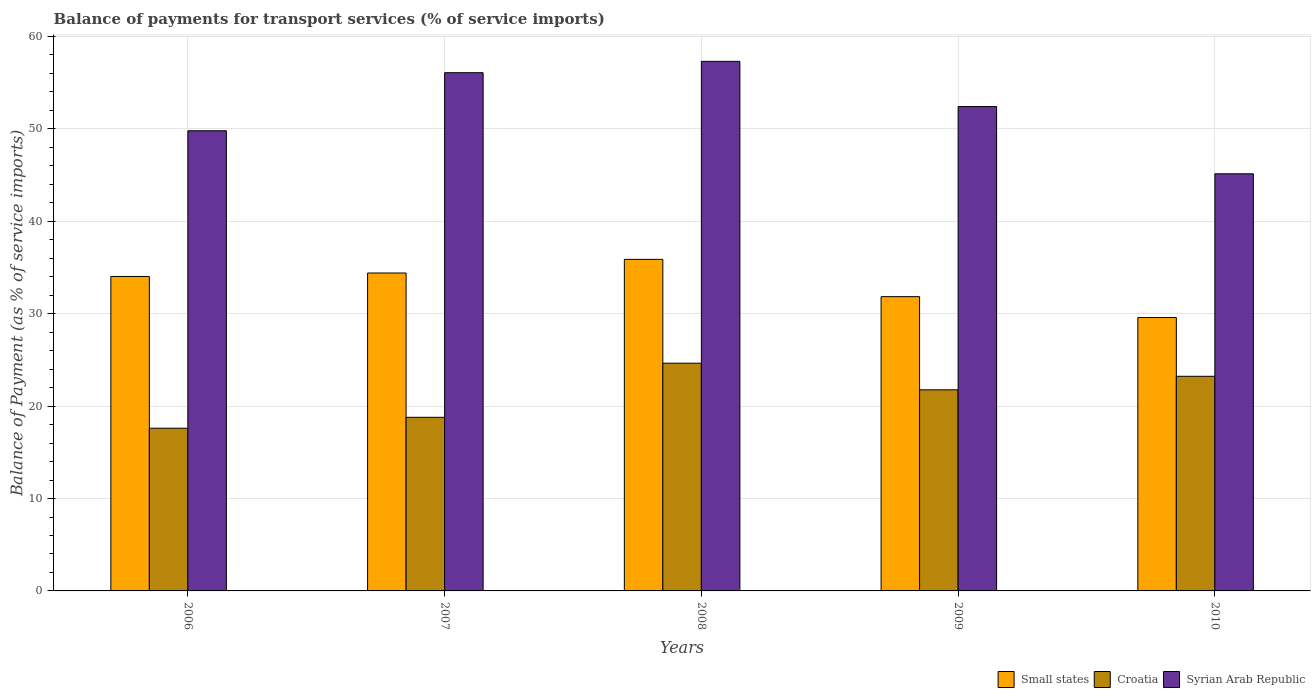Are the number of bars per tick equal to the number of legend labels?
Give a very brief answer. Yes. How many bars are there on the 2nd tick from the left?
Make the answer very short. 3. What is the label of the 4th group of bars from the left?
Your answer should be compact. 2009. What is the balance of payments for transport services in Small states in 2010?
Provide a short and direct response. 29.59. Across all years, what is the maximum balance of payments for transport services in Small states?
Make the answer very short. 35.88. Across all years, what is the minimum balance of payments for transport services in Syrian Arab Republic?
Give a very brief answer. 45.14. In which year was the balance of payments for transport services in Syrian Arab Republic maximum?
Ensure brevity in your answer.  2008. What is the total balance of payments for transport services in Small states in the graph?
Provide a short and direct response. 165.75. What is the difference between the balance of payments for transport services in Croatia in 2007 and that in 2010?
Provide a short and direct response. -4.44. What is the difference between the balance of payments for transport services in Small states in 2007 and the balance of payments for transport services in Syrian Arab Republic in 2010?
Your response must be concise. -10.74. What is the average balance of payments for transport services in Small states per year?
Make the answer very short. 33.15. In the year 2009, what is the difference between the balance of payments for transport services in Croatia and balance of payments for transport services in Small states?
Give a very brief answer. -10.08. In how many years, is the balance of payments for transport services in Syrian Arab Republic greater than 46 %?
Keep it short and to the point. 4. What is the ratio of the balance of payments for transport services in Syrian Arab Republic in 2008 to that in 2010?
Give a very brief answer. 1.27. What is the difference between the highest and the second highest balance of payments for transport services in Syrian Arab Republic?
Your answer should be very brief. 1.23. What is the difference between the highest and the lowest balance of payments for transport services in Syrian Arab Republic?
Offer a very short reply. 12.17. What does the 1st bar from the left in 2009 represents?
Give a very brief answer. Small states. What does the 3rd bar from the right in 2006 represents?
Provide a succinct answer. Small states. Is it the case that in every year, the sum of the balance of payments for transport services in Syrian Arab Republic and balance of payments for transport services in Small states is greater than the balance of payments for transport services in Croatia?
Provide a succinct answer. Yes. How many years are there in the graph?
Your answer should be compact. 5. What is the difference between two consecutive major ticks on the Y-axis?
Offer a terse response. 10. Does the graph contain grids?
Make the answer very short. Yes. Where does the legend appear in the graph?
Your answer should be very brief. Bottom right. What is the title of the graph?
Offer a terse response. Balance of payments for transport services (% of service imports). Does "Poland" appear as one of the legend labels in the graph?
Provide a succinct answer. No. What is the label or title of the Y-axis?
Offer a very short reply. Balance of Payment (as % of service imports). What is the Balance of Payment (as % of service imports) of Small states in 2006?
Give a very brief answer. 34.03. What is the Balance of Payment (as % of service imports) in Croatia in 2006?
Offer a terse response. 17.61. What is the Balance of Payment (as % of service imports) in Syrian Arab Republic in 2006?
Your answer should be very brief. 49.8. What is the Balance of Payment (as % of service imports) in Small states in 2007?
Give a very brief answer. 34.41. What is the Balance of Payment (as % of service imports) of Croatia in 2007?
Provide a short and direct response. 18.79. What is the Balance of Payment (as % of service imports) in Syrian Arab Republic in 2007?
Offer a terse response. 56.08. What is the Balance of Payment (as % of service imports) of Small states in 2008?
Your answer should be compact. 35.88. What is the Balance of Payment (as % of service imports) of Croatia in 2008?
Offer a very short reply. 24.65. What is the Balance of Payment (as % of service imports) of Syrian Arab Republic in 2008?
Your answer should be very brief. 57.31. What is the Balance of Payment (as % of service imports) in Small states in 2009?
Keep it short and to the point. 31.85. What is the Balance of Payment (as % of service imports) of Croatia in 2009?
Your response must be concise. 21.76. What is the Balance of Payment (as % of service imports) in Syrian Arab Republic in 2009?
Offer a very short reply. 52.42. What is the Balance of Payment (as % of service imports) of Small states in 2010?
Your answer should be compact. 29.59. What is the Balance of Payment (as % of service imports) in Croatia in 2010?
Keep it short and to the point. 23.23. What is the Balance of Payment (as % of service imports) in Syrian Arab Republic in 2010?
Give a very brief answer. 45.14. Across all years, what is the maximum Balance of Payment (as % of service imports) of Small states?
Your response must be concise. 35.88. Across all years, what is the maximum Balance of Payment (as % of service imports) in Croatia?
Make the answer very short. 24.65. Across all years, what is the maximum Balance of Payment (as % of service imports) in Syrian Arab Republic?
Your response must be concise. 57.31. Across all years, what is the minimum Balance of Payment (as % of service imports) in Small states?
Your response must be concise. 29.59. Across all years, what is the minimum Balance of Payment (as % of service imports) in Croatia?
Ensure brevity in your answer.  17.61. Across all years, what is the minimum Balance of Payment (as % of service imports) of Syrian Arab Republic?
Offer a terse response. 45.14. What is the total Balance of Payment (as % of service imports) of Small states in the graph?
Provide a short and direct response. 165.75. What is the total Balance of Payment (as % of service imports) of Croatia in the graph?
Your answer should be very brief. 106.04. What is the total Balance of Payment (as % of service imports) in Syrian Arab Republic in the graph?
Your answer should be compact. 260.76. What is the difference between the Balance of Payment (as % of service imports) in Small states in 2006 and that in 2007?
Offer a very short reply. -0.38. What is the difference between the Balance of Payment (as % of service imports) in Croatia in 2006 and that in 2007?
Make the answer very short. -1.18. What is the difference between the Balance of Payment (as % of service imports) of Syrian Arab Republic in 2006 and that in 2007?
Make the answer very short. -6.28. What is the difference between the Balance of Payment (as % of service imports) of Small states in 2006 and that in 2008?
Ensure brevity in your answer.  -1.85. What is the difference between the Balance of Payment (as % of service imports) of Croatia in 2006 and that in 2008?
Your answer should be very brief. -7.04. What is the difference between the Balance of Payment (as % of service imports) of Syrian Arab Republic in 2006 and that in 2008?
Keep it short and to the point. -7.51. What is the difference between the Balance of Payment (as % of service imports) in Small states in 2006 and that in 2009?
Your answer should be very brief. 2.18. What is the difference between the Balance of Payment (as % of service imports) of Croatia in 2006 and that in 2009?
Offer a very short reply. -4.15. What is the difference between the Balance of Payment (as % of service imports) in Syrian Arab Republic in 2006 and that in 2009?
Your answer should be very brief. -2.62. What is the difference between the Balance of Payment (as % of service imports) of Small states in 2006 and that in 2010?
Your answer should be very brief. 4.44. What is the difference between the Balance of Payment (as % of service imports) in Croatia in 2006 and that in 2010?
Make the answer very short. -5.62. What is the difference between the Balance of Payment (as % of service imports) of Syrian Arab Republic in 2006 and that in 2010?
Ensure brevity in your answer.  4.66. What is the difference between the Balance of Payment (as % of service imports) of Small states in 2007 and that in 2008?
Offer a very short reply. -1.48. What is the difference between the Balance of Payment (as % of service imports) in Croatia in 2007 and that in 2008?
Your answer should be compact. -5.86. What is the difference between the Balance of Payment (as % of service imports) in Syrian Arab Republic in 2007 and that in 2008?
Your response must be concise. -1.23. What is the difference between the Balance of Payment (as % of service imports) of Small states in 2007 and that in 2009?
Offer a terse response. 2.56. What is the difference between the Balance of Payment (as % of service imports) of Croatia in 2007 and that in 2009?
Provide a succinct answer. -2.97. What is the difference between the Balance of Payment (as % of service imports) of Syrian Arab Republic in 2007 and that in 2009?
Your answer should be compact. 3.66. What is the difference between the Balance of Payment (as % of service imports) in Small states in 2007 and that in 2010?
Offer a very short reply. 4.82. What is the difference between the Balance of Payment (as % of service imports) of Croatia in 2007 and that in 2010?
Provide a short and direct response. -4.44. What is the difference between the Balance of Payment (as % of service imports) of Syrian Arab Republic in 2007 and that in 2010?
Give a very brief answer. 10.94. What is the difference between the Balance of Payment (as % of service imports) of Small states in 2008 and that in 2009?
Your response must be concise. 4.03. What is the difference between the Balance of Payment (as % of service imports) in Croatia in 2008 and that in 2009?
Provide a short and direct response. 2.88. What is the difference between the Balance of Payment (as % of service imports) of Syrian Arab Republic in 2008 and that in 2009?
Your answer should be compact. 4.89. What is the difference between the Balance of Payment (as % of service imports) in Small states in 2008 and that in 2010?
Your answer should be compact. 6.3. What is the difference between the Balance of Payment (as % of service imports) of Croatia in 2008 and that in 2010?
Provide a succinct answer. 1.42. What is the difference between the Balance of Payment (as % of service imports) of Syrian Arab Republic in 2008 and that in 2010?
Make the answer very short. 12.17. What is the difference between the Balance of Payment (as % of service imports) of Small states in 2009 and that in 2010?
Your answer should be compact. 2.26. What is the difference between the Balance of Payment (as % of service imports) in Croatia in 2009 and that in 2010?
Your response must be concise. -1.46. What is the difference between the Balance of Payment (as % of service imports) of Syrian Arab Republic in 2009 and that in 2010?
Your response must be concise. 7.28. What is the difference between the Balance of Payment (as % of service imports) of Small states in 2006 and the Balance of Payment (as % of service imports) of Croatia in 2007?
Offer a terse response. 15.24. What is the difference between the Balance of Payment (as % of service imports) of Small states in 2006 and the Balance of Payment (as % of service imports) of Syrian Arab Republic in 2007?
Provide a succinct answer. -22.05. What is the difference between the Balance of Payment (as % of service imports) in Croatia in 2006 and the Balance of Payment (as % of service imports) in Syrian Arab Republic in 2007?
Your response must be concise. -38.47. What is the difference between the Balance of Payment (as % of service imports) in Small states in 2006 and the Balance of Payment (as % of service imports) in Croatia in 2008?
Keep it short and to the point. 9.38. What is the difference between the Balance of Payment (as % of service imports) in Small states in 2006 and the Balance of Payment (as % of service imports) in Syrian Arab Republic in 2008?
Keep it short and to the point. -23.28. What is the difference between the Balance of Payment (as % of service imports) in Croatia in 2006 and the Balance of Payment (as % of service imports) in Syrian Arab Republic in 2008?
Ensure brevity in your answer.  -39.7. What is the difference between the Balance of Payment (as % of service imports) of Small states in 2006 and the Balance of Payment (as % of service imports) of Croatia in 2009?
Your response must be concise. 12.27. What is the difference between the Balance of Payment (as % of service imports) of Small states in 2006 and the Balance of Payment (as % of service imports) of Syrian Arab Republic in 2009?
Your answer should be compact. -18.39. What is the difference between the Balance of Payment (as % of service imports) in Croatia in 2006 and the Balance of Payment (as % of service imports) in Syrian Arab Republic in 2009?
Provide a short and direct response. -34.81. What is the difference between the Balance of Payment (as % of service imports) of Small states in 2006 and the Balance of Payment (as % of service imports) of Croatia in 2010?
Your answer should be compact. 10.8. What is the difference between the Balance of Payment (as % of service imports) in Small states in 2006 and the Balance of Payment (as % of service imports) in Syrian Arab Republic in 2010?
Your response must be concise. -11.11. What is the difference between the Balance of Payment (as % of service imports) of Croatia in 2006 and the Balance of Payment (as % of service imports) of Syrian Arab Republic in 2010?
Give a very brief answer. -27.53. What is the difference between the Balance of Payment (as % of service imports) of Small states in 2007 and the Balance of Payment (as % of service imports) of Croatia in 2008?
Keep it short and to the point. 9.76. What is the difference between the Balance of Payment (as % of service imports) in Small states in 2007 and the Balance of Payment (as % of service imports) in Syrian Arab Republic in 2008?
Provide a succinct answer. -22.91. What is the difference between the Balance of Payment (as % of service imports) of Croatia in 2007 and the Balance of Payment (as % of service imports) of Syrian Arab Republic in 2008?
Ensure brevity in your answer.  -38.52. What is the difference between the Balance of Payment (as % of service imports) of Small states in 2007 and the Balance of Payment (as % of service imports) of Croatia in 2009?
Your response must be concise. 12.64. What is the difference between the Balance of Payment (as % of service imports) of Small states in 2007 and the Balance of Payment (as % of service imports) of Syrian Arab Republic in 2009?
Your response must be concise. -18.01. What is the difference between the Balance of Payment (as % of service imports) in Croatia in 2007 and the Balance of Payment (as % of service imports) in Syrian Arab Republic in 2009?
Give a very brief answer. -33.63. What is the difference between the Balance of Payment (as % of service imports) of Small states in 2007 and the Balance of Payment (as % of service imports) of Croatia in 2010?
Keep it short and to the point. 11.18. What is the difference between the Balance of Payment (as % of service imports) in Small states in 2007 and the Balance of Payment (as % of service imports) in Syrian Arab Republic in 2010?
Ensure brevity in your answer.  -10.74. What is the difference between the Balance of Payment (as % of service imports) in Croatia in 2007 and the Balance of Payment (as % of service imports) in Syrian Arab Republic in 2010?
Your response must be concise. -26.35. What is the difference between the Balance of Payment (as % of service imports) of Small states in 2008 and the Balance of Payment (as % of service imports) of Croatia in 2009?
Your response must be concise. 14.12. What is the difference between the Balance of Payment (as % of service imports) of Small states in 2008 and the Balance of Payment (as % of service imports) of Syrian Arab Republic in 2009?
Your answer should be compact. -16.54. What is the difference between the Balance of Payment (as % of service imports) in Croatia in 2008 and the Balance of Payment (as % of service imports) in Syrian Arab Republic in 2009?
Ensure brevity in your answer.  -27.77. What is the difference between the Balance of Payment (as % of service imports) in Small states in 2008 and the Balance of Payment (as % of service imports) in Croatia in 2010?
Your response must be concise. 12.65. What is the difference between the Balance of Payment (as % of service imports) of Small states in 2008 and the Balance of Payment (as % of service imports) of Syrian Arab Republic in 2010?
Your answer should be compact. -9.26. What is the difference between the Balance of Payment (as % of service imports) in Croatia in 2008 and the Balance of Payment (as % of service imports) in Syrian Arab Republic in 2010?
Provide a short and direct response. -20.5. What is the difference between the Balance of Payment (as % of service imports) in Small states in 2009 and the Balance of Payment (as % of service imports) in Croatia in 2010?
Offer a very short reply. 8.62. What is the difference between the Balance of Payment (as % of service imports) of Small states in 2009 and the Balance of Payment (as % of service imports) of Syrian Arab Republic in 2010?
Your answer should be very brief. -13.3. What is the difference between the Balance of Payment (as % of service imports) of Croatia in 2009 and the Balance of Payment (as % of service imports) of Syrian Arab Republic in 2010?
Provide a short and direct response. -23.38. What is the average Balance of Payment (as % of service imports) in Small states per year?
Offer a terse response. 33.15. What is the average Balance of Payment (as % of service imports) of Croatia per year?
Your answer should be very brief. 21.21. What is the average Balance of Payment (as % of service imports) in Syrian Arab Republic per year?
Keep it short and to the point. 52.15. In the year 2006, what is the difference between the Balance of Payment (as % of service imports) in Small states and Balance of Payment (as % of service imports) in Croatia?
Your answer should be very brief. 16.42. In the year 2006, what is the difference between the Balance of Payment (as % of service imports) in Small states and Balance of Payment (as % of service imports) in Syrian Arab Republic?
Offer a very short reply. -15.77. In the year 2006, what is the difference between the Balance of Payment (as % of service imports) in Croatia and Balance of Payment (as % of service imports) in Syrian Arab Republic?
Your response must be concise. -32.19. In the year 2007, what is the difference between the Balance of Payment (as % of service imports) in Small states and Balance of Payment (as % of service imports) in Croatia?
Your answer should be compact. 15.62. In the year 2007, what is the difference between the Balance of Payment (as % of service imports) of Small states and Balance of Payment (as % of service imports) of Syrian Arab Republic?
Give a very brief answer. -21.68. In the year 2007, what is the difference between the Balance of Payment (as % of service imports) in Croatia and Balance of Payment (as % of service imports) in Syrian Arab Republic?
Your answer should be compact. -37.29. In the year 2008, what is the difference between the Balance of Payment (as % of service imports) of Small states and Balance of Payment (as % of service imports) of Croatia?
Your answer should be compact. 11.24. In the year 2008, what is the difference between the Balance of Payment (as % of service imports) of Small states and Balance of Payment (as % of service imports) of Syrian Arab Republic?
Provide a short and direct response. -21.43. In the year 2008, what is the difference between the Balance of Payment (as % of service imports) of Croatia and Balance of Payment (as % of service imports) of Syrian Arab Republic?
Give a very brief answer. -32.67. In the year 2009, what is the difference between the Balance of Payment (as % of service imports) in Small states and Balance of Payment (as % of service imports) in Croatia?
Provide a succinct answer. 10.08. In the year 2009, what is the difference between the Balance of Payment (as % of service imports) in Small states and Balance of Payment (as % of service imports) in Syrian Arab Republic?
Your answer should be compact. -20.57. In the year 2009, what is the difference between the Balance of Payment (as % of service imports) of Croatia and Balance of Payment (as % of service imports) of Syrian Arab Republic?
Your answer should be compact. -30.66. In the year 2010, what is the difference between the Balance of Payment (as % of service imports) of Small states and Balance of Payment (as % of service imports) of Croatia?
Offer a terse response. 6.36. In the year 2010, what is the difference between the Balance of Payment (as % of service imports) of Small states and Balance of Payment (as % of service imports) of Syrian Arab Republic?
Offer a terse response. -15.56. In the year 2010, what is the difference between the Balance of Payment (as % of service imports) of Croatia and Balance of Payment (as % of service imports) of Syrian Arab Republic?
Provide a succinct answer. -21.92. What is the ratio of the Balance of Payment (as % of service imports) in Croatia in 2006 to that in 2007?
Keep it short and to the point. 0.94. What is the ratio of the Balance of Payment (as % of service imports) in Syrian Arab Republic in 2006 to that in 2007?
Give a very brief answer. 0.89. What is the ratio of the Balance of Payment (as % of service imports) of Small states in 2006 to that in 2008?
Offer a terse response. 0.95. What is the ratio of the Balance of Payment (as % of service imports) of Croatia in 2006 to that in 2008?
Your answer should be very brief. 0.71. What is the ratio of the Balance of Payment (as % of service imports) of Syrian Arab Republic in 2006 to that in 2008?
Ensure brevity in your answer.  0.87. What is the ratio of the Balance of Payment (as % of service imports) of Small states in 2006 to that in 2009?
Make the answer very short. 1.07. What is the ratio of the Balance of Payment (as % of service imports) of Croatia in 2006 to that in 2009?
Give a very brief answer. 0.81. What is the ratio of the Balance of Payment (as % of service imports) of Small states in 2006 to that in 2010?
Provide a short and direct response. 1.15. What is the ratio of the Balance of Payment (as % of service imports) in Croatia in 2006 to that in 2010?
Provide a short and direct response. 0.76. What is the ratio of the Balance of Payment (as % of service imports) in Syrian Arab Republic in 2006 to that in 2010?
Provide a short and direct response. 1.1. What is the ratio of the Balance of Payment (as % of service imports) in Small states in 2007 to that in 2008?
Your answer should be very brief. 0.96. What is the ratio of the Balance of Payment (as % of service imports) of Croatia in 2007 to that in 2008?
Make the answer very short. 0.76. What is the ratio of the Balance of Payment (as % of service imports) of Syrian Arab Republic in 2007 to that in 2008?
Your answer should be very brief. 0.98. What is the ratio of the Balance of Payment (as % of service imports) of Small states in 2007 to that in 2009?
Provide a short and direct response. 1.08. What is the ratio of the Balance of Payment (as % of service imports) in Croatia in 2007 to that in 2009?
Keep it short and to the point. 0.86. What is the ratio of the Balance of Payment (as % of service imports) in Syrian Arab Republic in 2007 to that in 2009?
Provide a succinct answer. 1.07. What is the ratio of the Balance of Payment (as % of service imports) in Small states in 2007 to that in 2010?
Offer a terse response. 1.16. What is the ratio of the Balance of Payment (as % of service imports) of Croatia in 2007 to that in 2010?
Make the answer very short. 0.81. What is the ratio of the Balance of Payment (as % of service imports) in Syrian Arab Republic in 2007 to that in 2010?
Offer a terse response. 1.24. What is the ratio of the Balance of Payment (as % of service imports) of Small states in 2008 to that in 2009?
Give a very brief answer. 1.13. What is the ratio of the Balance of Payment (as % of service imports) in Croatia in 2008 to that in 2009?
Provide a short and direct response. 1.13. What is the ratio of the Balance of Payment (as % of service imports) in Syrian Arab Republic in 2008 to that in 2009?
Your answer should be very brief. 1.09. What is the ratio of the Balance of Payment (as % of service imports) in Small states in 2008 to that in 2010?
Your response must be concise. 1.21. What is the ratio of the Balance of Payment (as % of service imports) of Croatia in 2008 to that in 2010?
Ensure brevity in your answer.  1.06. What is the ratio of the Balance of Payment (as % of service imports) in Syrian Arab Republic in 2008 to that in 2010?
Keep it short and to the point. 1.27. What is the ratio of the Balance of Payment (as % of service imports) in Small states in 2009 to that in 2010?
Ensure brevity in your answer.  1.08. What is the ratio of the Balance of Payment (as % of service imports) in Croatia in 2009 to that in 2010?
Provide a short and direct response. 0.94. What is the ratio of the Balance of Payment (as % of service imports) of Syrian Arab Republic in 2009 to that in 2010?
Make the answer very short. 1.16. What is the difference between the highest and the second highest Balance of Payment (as % of service imports) of Small states?
Provide a succinct answer. 1.48. What is the difference between the highest and the second highest Balance of Payment (as % of service imports) in Croatia?
Provide a succinct answer. 1.42. What is the difference between the highest and the second highest Balance of Payment (as % of service imports) in Syrian Arab Republic?
Your response must be concise. 1.23. What is the difference between the highest and the lowest Balance of Payment (as % of service imports) of Small states?
Provide a short and direct response. 6.3. What is the difference between the highest and the lowest Balance of Payment (as % of service imports) of Croatia?
Your answer should be compact. 7.04. What is the difference between the highest and the lowest Balance of Payment (as % of service imports) of Syrian Arab Republic?
Make the answer very short. 12.17. 